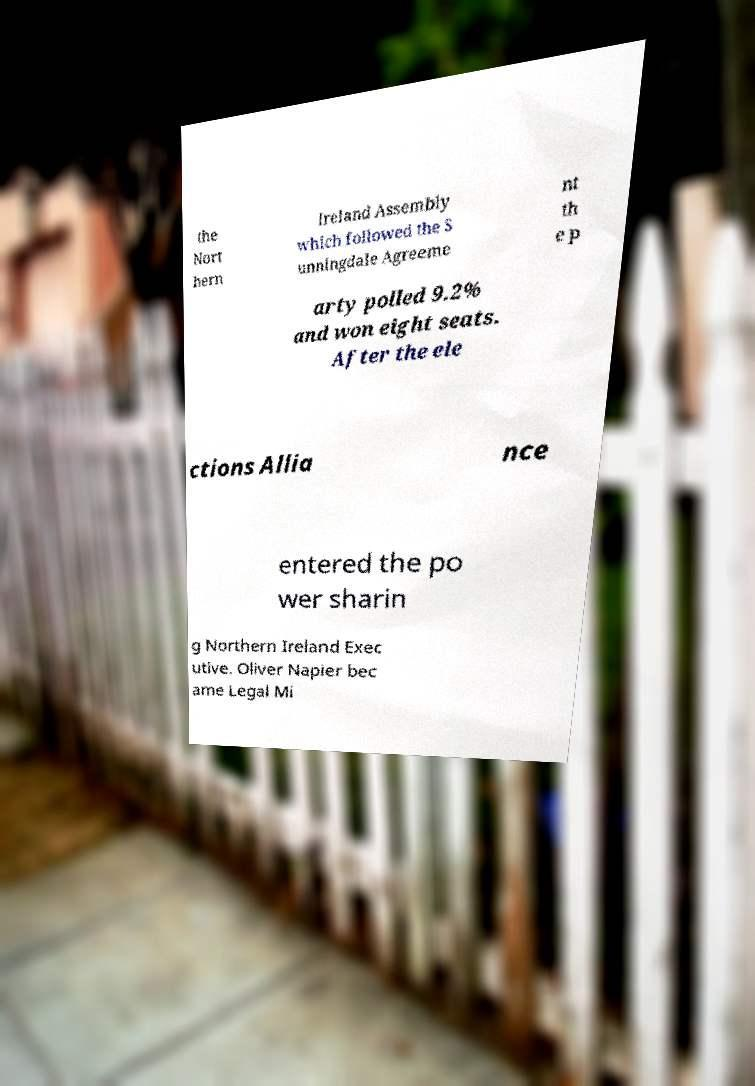Please identify and transcribe the text found in this image. the Nort hern Ireland Assembly which followed the S unningdale Agreeme nt th e p arty polled 9.2% and won eight seats. After the ele ctions Allia nce entered the po wer sharin g Northern Ireland Exec utive. Oliver Napier bec ame Legal Mi 